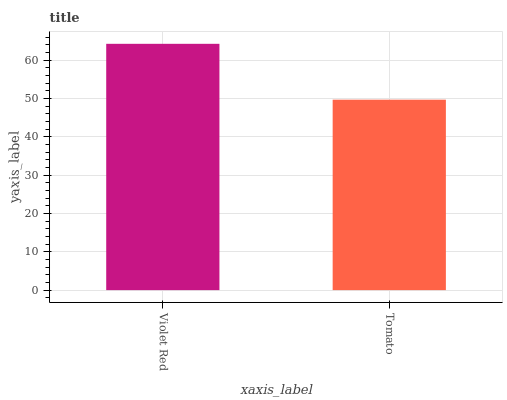Is Tomato the minimum?
Answer yes or no. Yes. Is Violet Red the maximum?
Answer yes or no. Yes. Is Tomato the maximum?
Answer yes or no. No. Is Violet Red greater than Tomato?
Answer yes or no. Yes. Is Tomato less than Violet Red?
Answer yes or no. Yes. Is Tomato greater than Violet Red?
Answer yes or no. No. Is Violet Red less than Tomato?
Answer yes or no. No. Is Violet Red the high median?
Answer yes or no. Yes. Is Tomato the low median?
Answer yes or no. Yes. Is Tomato the high median?
Answer yes or no. No. Is Violet Red the low median?
Answer yes or no. No. 